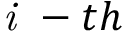Convert formula to latex. <formula><loc_0><loc_0><loc_500><loc_500>i - t h</formula> 